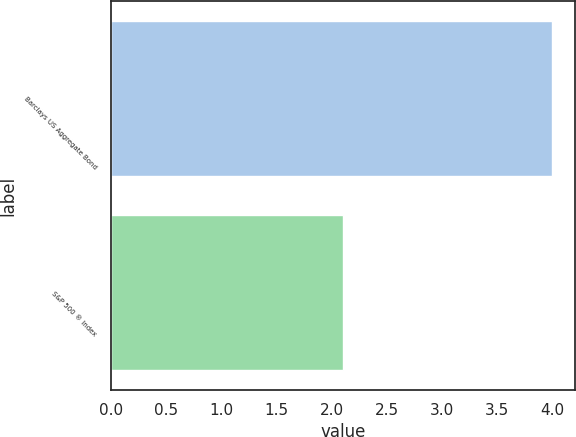<chart> <loc_0><loc_0><loc_500><loc_500><bar_chart><fcel>Barclays US Aggregate Bond<fcel>S&P 500 ® Index<nl><fcel>4<fcel>2.1<nl></chart> 